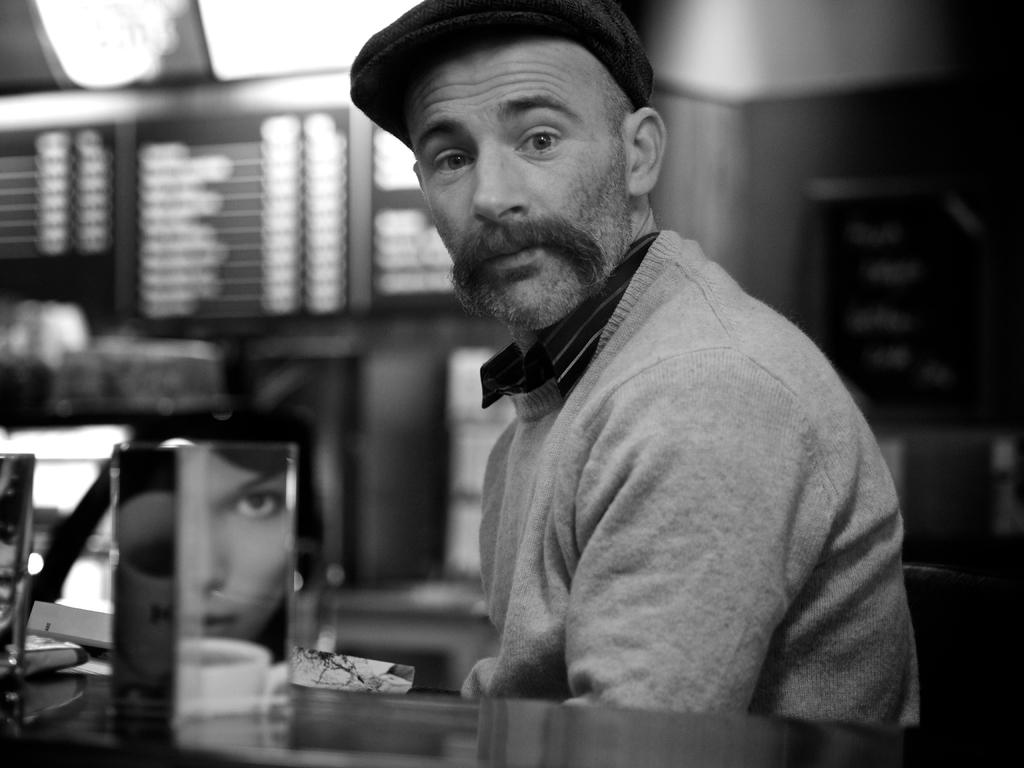What is the color scheme of the image? The image is black and white. Who is present in the image? There is a man in the image. What object is in front of the man? There is a glass on a surface in front of the man. Whose face can be seen in the image? A person's face is visible in the image. What other beverage container is present in the image? There is a cup in the image. How would you describe the background of the image? The background of the image is blurred. What type of writing can be seen on the faucet in the image? There is no faucet present in the image, so no writing can be seen on it. What type of farming equipment is the farmer using in the image? There is no farmer or farming equipment present in the image. 